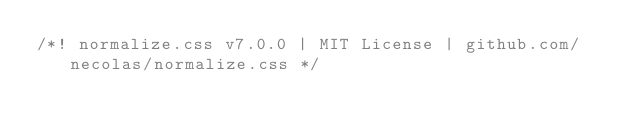<code> <loc_0><loc_0><loc_500><loc_500><_CSS_>/*! normalize.css v7.0.0 | MIT License | github.com/necolas/normalize.css */</code> 